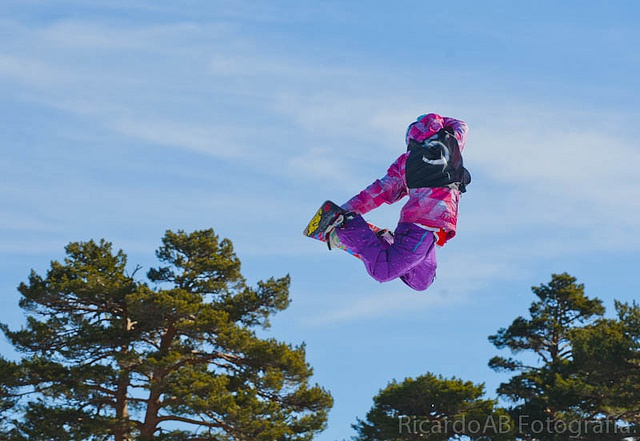Describe the objects in this image and their specific colors. I can see people in lightblue, black, purple, and navy tones and snowboard in lightblue, black, navy, gray, and olive tones in this image. 